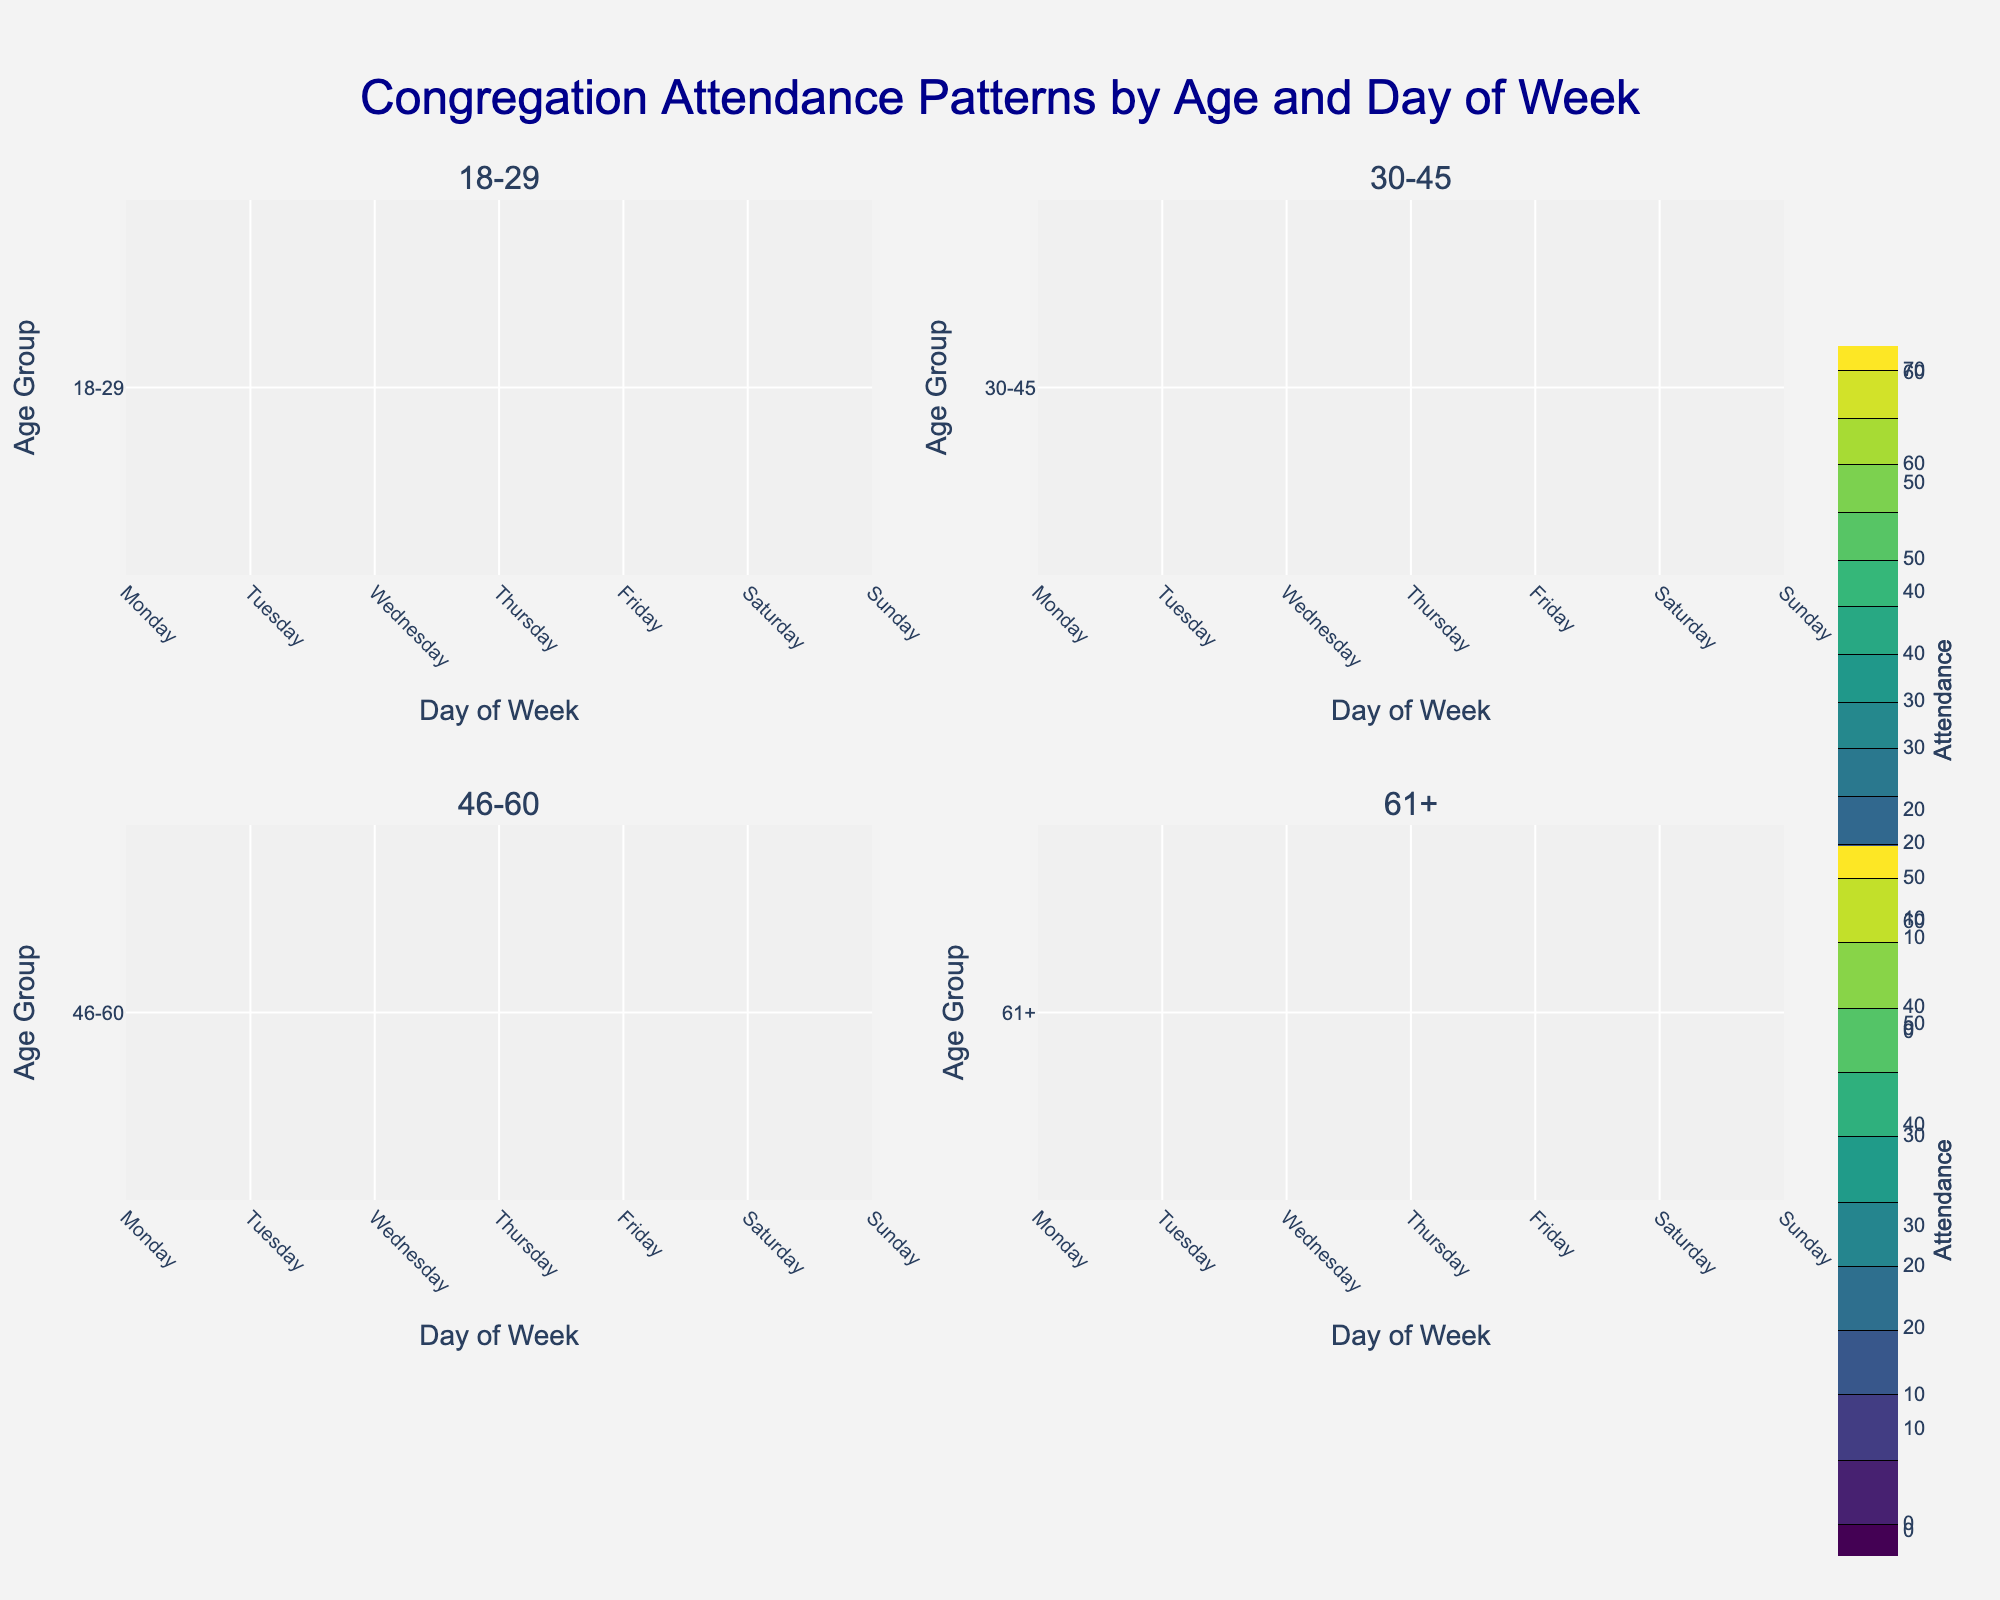Which age group has the highest attendance on Sundays? The contour plots will show different attendance levels across age groups and days of the week. Looking at the subplot titles, we identify the attendance levels on Sundays for each age group. The 30-45 age group shows the highest attendance level on Sundays.
Answer: 30-45 What is the weekday with the lowest attendance for the 61+ age group? Looking at the subplot for the 61+ age group, check each day from Monday to Friday. The attendance on Monday and Tuesday is the lowest for this age group.
Answer: Monday and Tuesday On which days does the 18-29 age group show an increasing pattern of attendance? Examine the subplot for the 18-29 age group and look for days when attendance increases sequentially. Attendance increases from Monday to Sunday for the 18-29 age group.
Answer: Monday to Sunday How does the attendance pattern differ between Saturday and Sunday for the 46-60 age group? Compare the contour levels for Saturday and Sunday for the 46-60 age group. The attendance increases from Saturday (45) to Sunday (65).
Answer: Increases from 45 to 65 Which age group shows the most significant increase in attendance from Wednesday to Thursday? Check Wednesday and Thursday attendance levels for each age group and compare the differences. The 18-29 age group shows an increase from 20 to 25.
Answer: 18-29 What is the range of attendance values for the 30-45 age group across all days? Identify the minimum and maximum attendance values for the 30-45 age group by checking its subplot. The range is from 20 (Tuesday) to 70 (Sunday).
Answer: 20 to 70 Among all age groups, which has the largest variation in attendance throughout the week? Compare the highest attendance difference between days within each age group. The maximum variation is in the 30-45 age group, varying from 20 (Tuesday) to 70 (Sunday).
Answer: 30-45 Which day shows the lowest attendance for the 46-60 age group? Check which day has the smallest attendance value within the 46-60 age group. The lowest attendance is on Tuesday with 15 attendees.
Answer: Tuesday What trend can be observed for the 61+ age group from Friday to Sunday? Examine the subplot for the 61+ age group and identify the attendance pattern from Friday to Sunday. The trend shows an increase from 25 (Friday) to 50 (Sunday).
Answer: Increasing How does the attendance on Monday compare between the 18-29 and 46-60 age groups? Look at the plot values for Monday attendance within the 18-29 and 46-60 subplots. The 46-60 age group has a higher attendance (20) than the 18-29 age group (15) on Monday.
Answer: 46-60 has higher attendance 